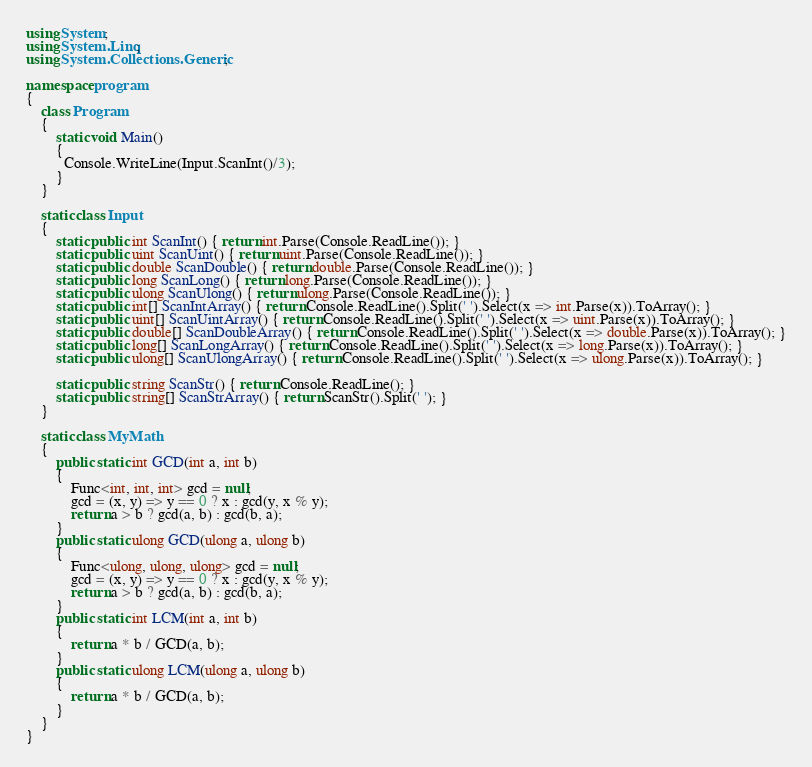<code> <loc_0><loc_0><loc_500><loc_500><_C#_>using System;
using System.Linq;
using System.Collections.Generic;

namespace program
{
    class Program
    {
        static void Main()
        {
          Console.WriteLine(Input.ScanInt()/3);
        }
    }

    static class Input
    {
        static public int ScanInt() { return int.Parse(Console.ReadLine()); }
        static public uint ScanUint() { return uint.Parse(Console.ReadLine()); }
        static public double ScanDouble() { return double.Parse(Console.ReadLine()); }
        static public long ScanLong() { return long.Parse(Console.ReadLine()); }
        static public ulong ScanUlong() { return ulong.Parse(Console.ReadLine()); }
        static public int[] ScanIntArray() { return Console.ReadLine().Split(' ').Select(x => int.Parse(x)).ToArray(); }
        static public uint[] ScanUintArray() { return Console.ReadLine().Split(' ').Select(x => uint.Parse(x)).ToArray(); }
        static public double[] ScanDoubleArray() { return Console.ReadLine().Split(' ').Select(x => double.Parse(x)).ToArray(); }
        static public long[] ScanLongArray() { return Console.ReadLine().Split(' ').Select(x => long.Parse(x)).ToArray(); }
        static public ulong[] ScanUlongArray() { return Console.ReadLine().Split(' ').Select(x => ulong.Parse(x)).ToArray(); }

        static public string ScanStr() { return Console.ReadLine(); }
        static public string[] ScanStrArray() { return ScanStr().Split(' '); }
    }

    static class MyMath
    {
        public static int GCD(int a, int b)
        {
            Func<int, int, int> gcd = null;
            gcd = (x, y) => y == 0 ? x : gcd(y, x % y);
            return a > b ? gcd(a, b) : gcd(b, a);
        }
        public static ulong GCD(ulong a, ulong b)
        {
            Func<ulong, ulong, ulong> gcd = null;
            gcd = (x, y) => y == 0 ? x : gcd(y, x % y);
            return a > b ? gcd(a, b) : gcd(b, a);
        }
        public static int LCM(int a, int b)
        {
            return a * b / GCD(a, b);
        }
        public static ulong LCM(ulong a, ulong b)
        {
            return a * b / GCD(a, b);
        }
    }
}
</code> 